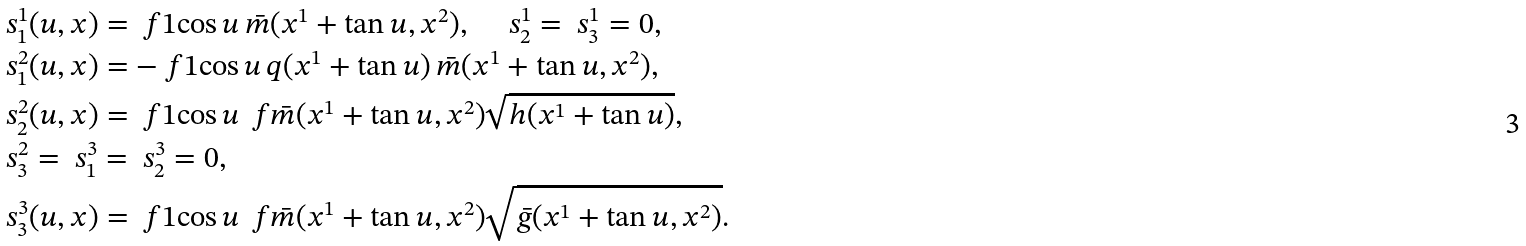Convert formula to latex. <formula><loc_0><loc_0><loc_500><loc_500>& \ s _ { 1 } ^ { 1 } ( u , x ) = \ f 1 { \cos u } \, \bar { m } ( x ^ { 1 } + \tan u , x ^ { 2 } ) , \quad \ s _ { 2 } ^ { 1 } = \ s _ { 3 } ^ { 1 } = 0 , \\ & \ s _ { 1 } ^ { 2 } ( u , x ) = - \ f 1 { \cos u } \, q ( x ^ { 1 } + \tan u ) \, \bar { m } ( x ^ { 1 } + \tan u , x ^ { 2 } ) , \\ & \ s _ { 2 } ^ { 2 } ( u , x ) = \ f 1 { \cos u } \, \ f { \bar { m } ( x ^ { 1 } + \tan u , x ^ { 2 } ) } { \sqrt { h ( x ^ { 1 } + \tan u ) } } , \\ & \ s _ { 3 } ^ { 2 } = \ s _ { 1 } ^ { 3 } = \ s _ { 2 } ^ { 3 } = 0 , \\ & \ s _ { 3 } ^ { 3 } ( u , x ) = \ f 1 { \cos u } \, \ f { \bar { m } ( x ^ { 1 } + \tan u , x ^ { 2 } ) } { \sqrt { \bar { g } ( x ^ { 1 } + \tan u , x ^ { 2 } ) } } .</formula> 